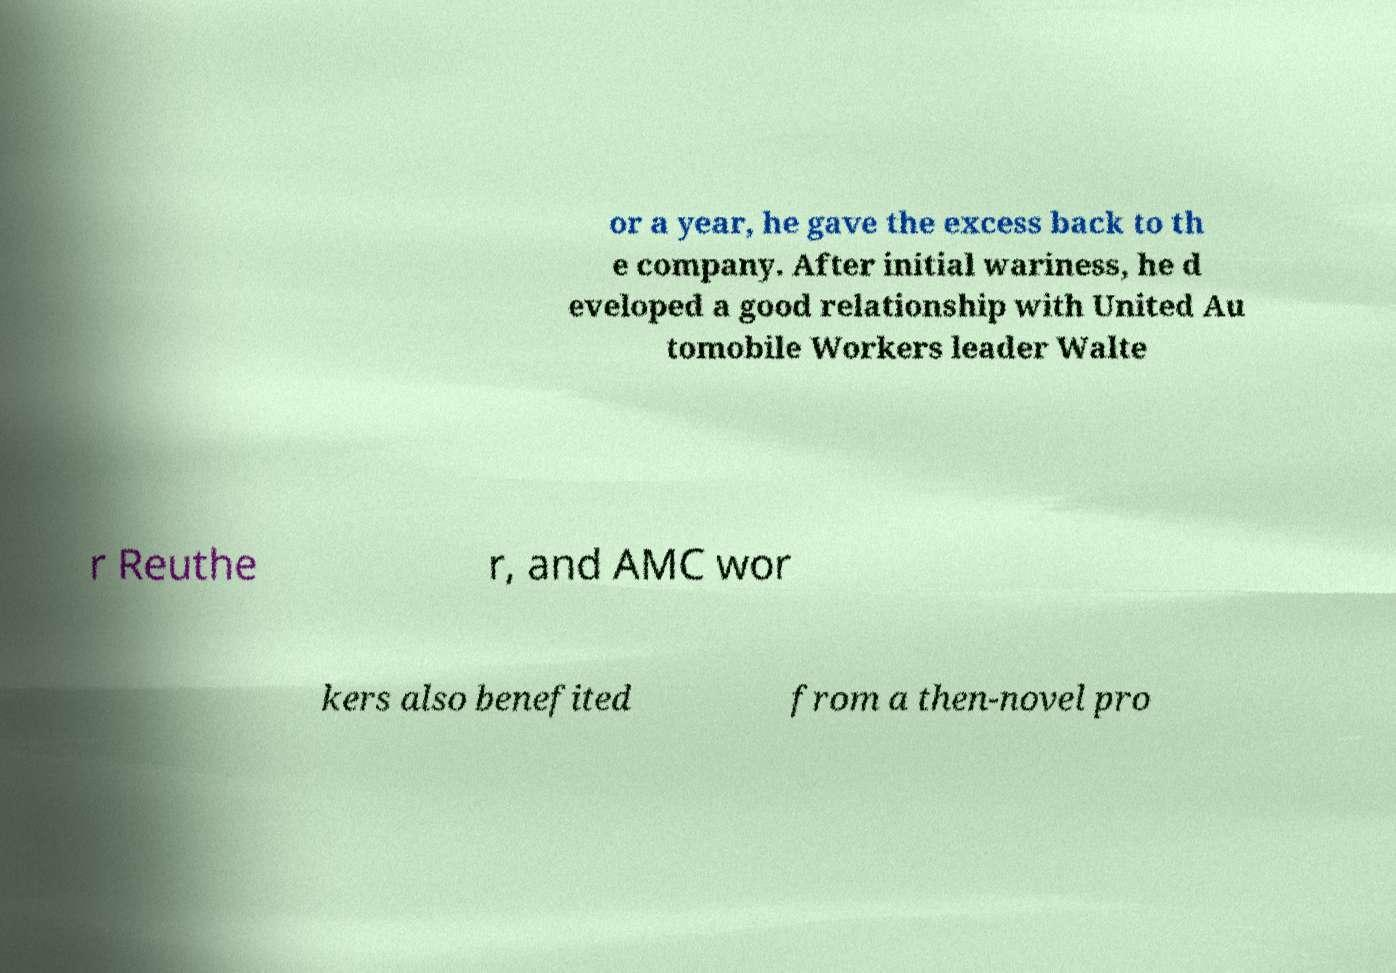Could you extract and type out the text from this image? or a year, he gave the excess back to th e company. After initial wariness, he d eveloped a good relationship with United Au tomobile Workers leader Walte r Reuthe r, and AMC wor kers also benefited from a then-novel pro 